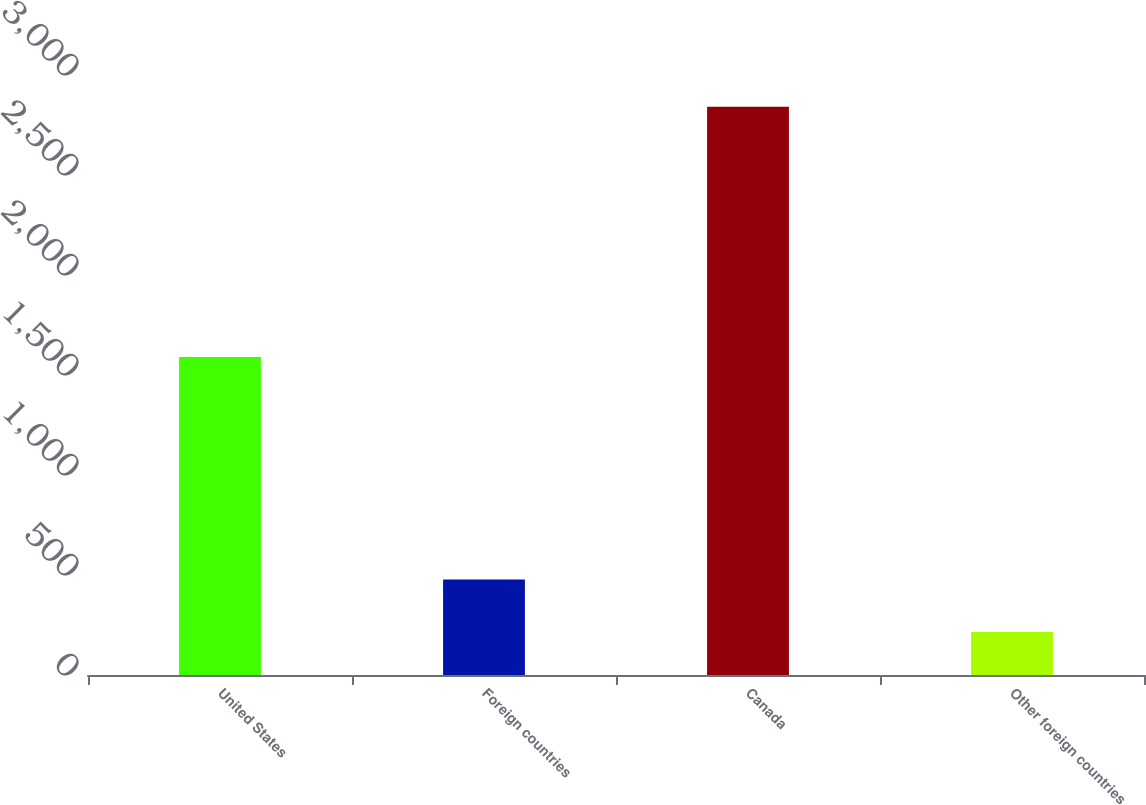<chart> <loc_0><loc_0><loc_500><loc_500><bar_chart><fcel>United States<fcel>Foreign countries<fcel>Canada<fcel>Other foreign countries<nl><fcel>1590<fcel>477.6<fcel>2841<fcel>215<nl></chart> 